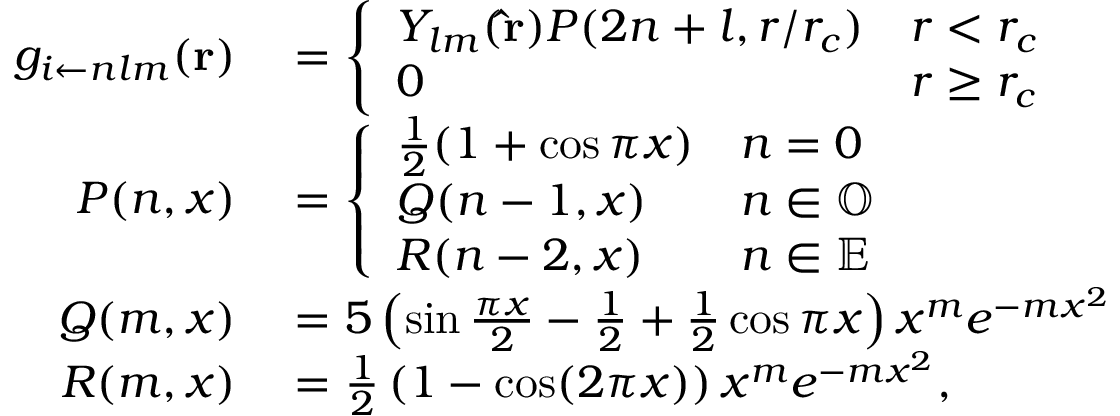Convert formula to latex. <formula><loc_0><loc_0><loc_500><loc_500>\begin{array} { r l } { g _ { i \leftarrow n l m } ( r ) } & = \left \{ \begin{array} { l l } { Y _ { l m } ( \hat { r } ) P ( 2 n + l , r / r _ { c } ) } & { r < r _ { c } } \\ { 0 } & { r \geq r _ { c } } \end{array} } \\ { P ( n , x ) } & = \left \{ \begin{array} { l l } { \frac { 1 } { 2 } ( 1 + \cos \pi x ) } & { n = 0 } \\ { Q ( n - 1 , x ) } & { n \in \mathbb { O } } \\ { R ( n - 2 , x ) } & { n \in \mathbb { E } } \end{array} } \\ { Q ( m , x ) } & = 5 \left ( \sin \frac { \pi x } { 2 } - \frac { 1 } { 2 } + \frac { 1 } { 2 } \cos \pi x \right ) x ^ { m } e ^ { - m x ^ { 2 } } } \\ { R ( m , x ) } & = \frac { 1 } { 2 } \left ( 1 - \cos ( 2 \pi x ) \right ) x ^ { m } e ^ { - m x ^ { 2 } } , } \end{array}</formula> 